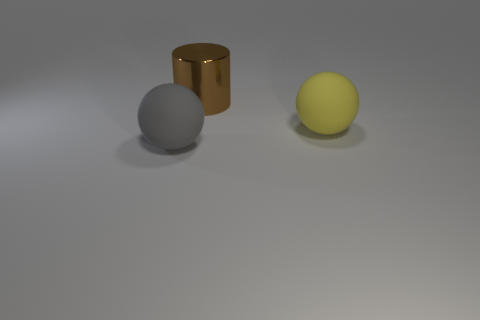What colors are the objects in the image? The objects consist of three colors: the cylinder is copper-colored, the sphere on the left is gray, while the sphere on the right is yellow. 